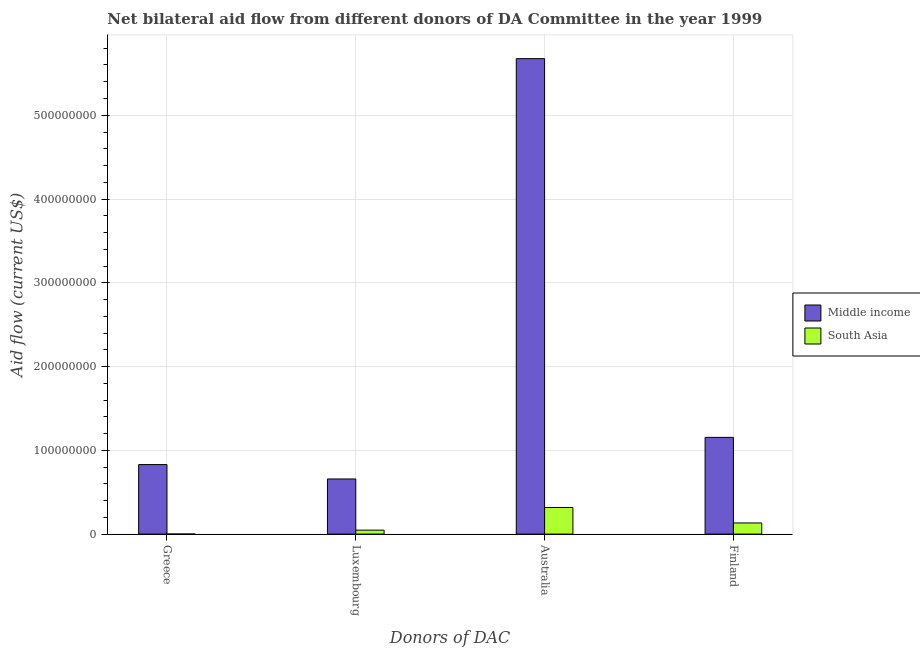How many groups of bars are there?
Offer a very short reply. 4. How many bars are there on the 4th tick from the left?
Make the answer very short. 2. What is the amount of aid given by australia in South Asia?
Provide a succinct answer. 3.18e+07. Across all countries, what is the maximum amount of aid given by australia?
Make the answer very short. 5.68e+08. Across all countries, what is the minimum amount of aid given by greece?
Your response must be concise. 7.00e+04. In which country was the amount of aid given by australia maximum?
Make the answer very short. Middle income. What is the total amount of aid given by luxembourg in the graph?
Offer a terse response. 7.05e+07. What is the difference between the amount of aid given by greece in Middle income and that in South Asia?
Offer a terse response. 8.29e+07. What is the difference between the amount of aid given by greece in Middle income and the amount of aid given by luxembourg in South Asia?
Make the answer very short. 7.83e+07. What is the average amount of aid given by finland per country?
Ensure brevity in your answer.  6.44e+07. What is the difference between the amount of aid given by finland and amount of aid given by greece in South Asia?
Your answer should be compact. 1.32e+07. In how many countries, is the amount of aid given by greece greater than 180000000 US$?
Your answer should be compact. 0. What is the ratio of the amount of aid given by australia in Middle income to that in South Asia?
Make the answer very short. 17.86. Is the amount of aid given by australia in South Asia less than that in Middle income?
Keep it short and to the point. Yes. Is the difference between the amount of aid given by luxembourg in South Asia and Middle income greater than the difference between the amount of aid given by greece in South Asia and Middle income?
Offer a terse response. Yes. What is the difference between the highest and the second highest amount of aid given by luxembourg?
Offer a very short reply. 6.11e+07. What is the difference between the highest and the lowest amount of aid given by finland?
Keep it short and to the point. 1.02e+08. In how many countries, is the amount of aid given by luxembourg greater than the average amount of aid given by luxembourg taken over all countries?
Your response must be concise. 1. Is the sum of the amount of aid given by greece in Middle income and South Asia greater than the maximum amount of aid given by luxembourg across all countries?
Your answer should be compact. Yes. Is it the case that in every country, the sum of the amount of aid given by greece and amount of aid given by finland is greater than the sum of amount of aid given by luxembourg and amount of aid given by australia?
Your response must be concise. No. What does the 2nd bar from the left in Australia represents?
Offer a very short reply. South Asia. What does the 2nd bar from the right in Australia represents?
Keep it short and to the point. Middle income. Is it the case that in every country, the sum of the amount of aid given by greece and amount of aid given by luxembourg is greater than the amount of aid given by australia?
Offer a terse response. No. How many bars are there?
Offer a terse response. 8. What is the difference between two consecutive major ticks on the Y-axis?
Your response must be concise. 1.00e+08. Does the graph contain any zero values?
Your answer should be compact. No. Does the graph contain grids?
Provide a succinct answer. Yes. How many legend labels are there?
Your answer should be very brief. 2. What is the title of the graph?
Your answer should be very brief. Net bilateral aid flow from different donors of DA Committee in the year 1999. What is the label or title of the X-axis?
Ensure brevity in your answer.  Donors of DAC. What is the Aid flow (current US$) in Middle income in Greece?
Ensure brevity in your answer.  8.30e+07. What is the Aid flow (current US$) in Middle income in Luxembourg?
Provide a succinct answer. 6.58e+07. What is the Aid flow (current US$) of South Asia in Luxembourg?
Your answer should be compact. 4.72e+06. What is the Aid flow (current US$) of Middle income in Australia?
Give a very brief answer. 5.68e+08. What is the Aid flow (current US$) of South Asia in Australia?
Ensure brevity in your answer.  3.18e+07. What is the Aid flow (current US$) in Middle income in Finland?
Provide a succinct answer. 1.15e+08. What is the Aid flow (current US$) of South Asia in Finland?
Keep it short and to the point. 1.33e+07. Across all Donors of DAC, what is the maximum Aid flow (current US$) of Middle income?
Provide a short and direct response. 5.68e+08. Across all Donors of DAC, what is the maximum Aid flow (current US$) of South Asia?
Provide a short and direct response. 3.18e+07. Across all Donors of DAC, what is the minimum Aid flow (current US$) in Middle income?
Offer a very short reply. 6.58e+07. What is the total Aid flow (current US$) in Middle income in the graph?
Make the answer very short. 8.32e+08. What is the total Aid flow (current US$) of South Asia in the graph?
Offer a terse response. 4.99e+07. What is the difference between the Aid flow (current US$) of Middle income in Greece and that in Luxembourg?
Your answer should be compact. 1.72e+07. What is the difference between the Aid flow (current US$) in South Asia in Greece and that in Luxembourg?
Offer a terse response. -4.65e+06. What is the difference between the Aid flow (current US$) in Middle income in Greece and that in Australia?
Offer a very short reply. -4.85e+08. What is the difference between the Aid flow (current US$) of South Asia in Greece and that in Australia?
Offer a terse response. -3.17e+07. What is the difference between the Aid flow (current US$) in Middle income in Greece and that in Finland?
Give a very brief answer. -3.25e+07. What is the difference between the Aid flow (current US$) in South Asia in Greece and that in Finland?
Offer a terse response. -1.32e+07. What is the difference between the Aid flow (current US$) of Middle income in Luxembourg and that in Australia?
Your answer should be compact. -5.02e+08. What is the difference between the Aid flow (current US$) of South Asia in Luxembourg and that in Australia?
Ensure brevity in your answer.  -2.71e+07. What is the difference between the Aid flow (current US$) in Middle income in Luxembourg and that in Finland?
Make the answer very short. -4.96e+07. What is the difference between the Aid flow (current US$) of South Asia in Luxembourg and that in Finland?
Your answer should be compact. -8.58e+06. What is the difference between the Aid flow (current US$) of Middle income in Australia and that in Finland?
Give a very brief answer. 4.52e+08. What is the difference between the Aid flow (current US$) in South Asia in Australia and that in Finland?
Make the answer very short. 1.85e+07. What is the difference between the Aid flow (current US$) of Middle income in Greece and the Aid flow (current US$) of South Asia in Luxembourg?
Provide a short and direct response. 7.83e+07. What is the difference between the Aid flow (current US$) of Middle income in Greece and the Aid flow (current US$) of South Asia in Australia?
Make the answer very short. 5.12e+07. What is the difference between the Aid flow (current US$) of Middle income in Greece and the Aid flow (current US$) of South Asia in Finland?
Your response must be concise. 6.97e+07. What is the difference between the Aid flow (current US$) of Middle income in Luxembourg and the Aid flow (current US$) of South Asia in Australia?
Your answer should be very brief. 3.40e+07. What is the difference between the Aid flow (current US$) in Middle income in Luxembourg and the Aid flow (current US$) in South Asia in Finland?
Offer a very short reply. 5.25e+07. What is the difference between the Aid flow (current US$) in Middle income in Australia and the Aid flow (current US$) in South Asia in Finland?
Ensure brevity in your answer.  5.54e+08. What is the average Aid flow (current US$) in Middle income per Donors of DAC?
Your response must be concise. 2.08e+08. What is the average Aid flow (current US$) in South Asia per Donors of DAC?
Keep it short and to the point. 1.25e+07. What is the difference between the Aid flow (current US$) in Middle income and Aid flow (current US$) in South Asia in Greece?
Your answer should be very brief. 8.29e+07. What is the difference between the Aid flow (current US$) in Middle income and Aid flow (current US$) in South Asia in Luxembourg?
Offer a terse response. 6.11e+07. What is the difference between the Aid flow (current US$) of Middle income and Aid flow (current US$) of South Asia in Australia?
Your response must be concise. 5.36e+08. What is the difference between the Aid flow (current US$) in Middle income and Aid flow (current US$) in South Asia in Finland?
Your answer should be very brief. 1.02e+08. What is the ratio of the Aid flow (current US$) in Middle income in Greece to that in Luxembourg?
Provide a short and direct response. 1.26. What is the ratio of the Aid flow (current US$) in South Asia in Greece to that in Luxembourg?
Ensure brevity in your answer.  0.01. What is the ratio of the Aid flow (current US$) in Middle income in Greece to that in Australia?
Give a very brief answer. 0.15. What is the ratio of the Aid flow (current US$) in South Asia in Greece to that in Australia?
Keep it short and to the point. 0. What is the ratio of the Aid flow (current US$) in Middle income in Greece to that in Finland?
Your response must be concise. 0.72. What is the ratio of the Aid flow (current US$) in South Asia in Greece to that in Finland?
Provide a succinct answer. 0.01. What is the ratio of the Aid flow (current US$) in Middle income in Luxembourg to that in Australia?
Give a very brief answer. 0.12. What is the ratio of the Aid flow (current US$) of South Asia in Luxembourg to that in Australia?
Offer a terse response. 0.15. What is the ratio of the Aid flow (current US$) in Middle income in Luxembourg to that in Finland?
Give a very brief answer. 0.57. What is the ratio of the Aid flow (current US$) in South Asia in Luxembourg to that in Finland?
Give a very brief answer. 0.35. What is the ratio of the Aid flow (current US$) in Middle income in Australia to that in Finland?
Give a very brief answer. 4.92. What is the ratio of the Aid flow (current US$) of South Asia in Australia to that in Finland?
Keep it short and to the point. 2.39. What is the difference between the highest and the second highest Aid flow (current US$) of Middle income?
Keep it short and to the point. 4.52e+08. What is the difference between the highest and the second highest Aid flow (current US$) in South Asia?
Keep it short and to the point. 1.85e+07. What is the difference between the highest and the lowest Aid flow (current US$) in Middle income?
Your response must be concise. 5.02e+08. What is the difference between the highest and the lowest Aid flow (current US$) of South Asia?
Ensure brevity in your answer.  3.17e+07. 